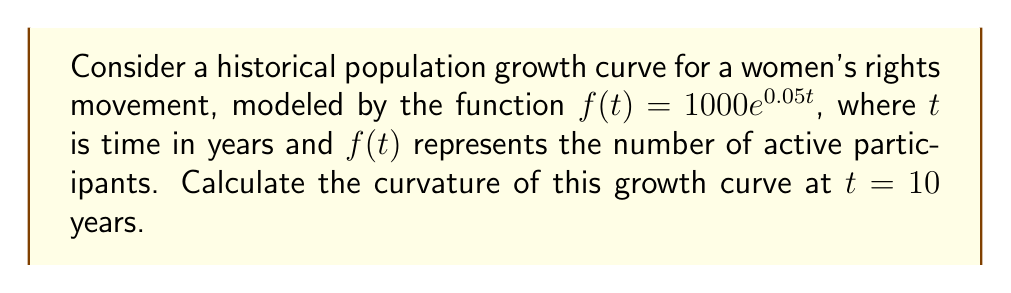Help me with this question. To calculate the curvature of the given curve, we'll follow these steps:

1) The formula for curvature $\kappa$ of a function $y = f(x)$ is:

   $$\kappa = \frac{|f''(x)|}{(1 + (f'(x))^2)^{3/2}}$$

2) In our case, $f(t) = 1000e^{0.05t}$. Let's calculate $f'(t)$ and $f''(t)$:

   $f'(t) = 1000 \cdot 0.05e^{0.05t} = 50e^{0.05t}$
   $f''(t) = 50 \cdot 0.05e^{0.05t} = 2.5e^{0.05t}$

3) Now, let's substitute $t = 10$ into these expressions:

   $f'(10) = 50e^{0.5} \approx 82.44$
   $f''(10) = 2.5e^{0.5} \approx 4.12$

4) Plugging these values into the curvature formula:

   $$\kappa = \frac{|4.12|}{(1 + (82.44)^2)^{3/2}}$$

5) Simplify:
   $$\kappa = \frac{4.12}{(1 + 6796.35)^{3/2}} = \frac{4.12}{(6797.35)^{3/2}}$$

6) Calculate the final result:
   $$\kappa \approx 5.87 \times 10^{-6}$$
Answer: $5.87 \times 10^{-6}$ 